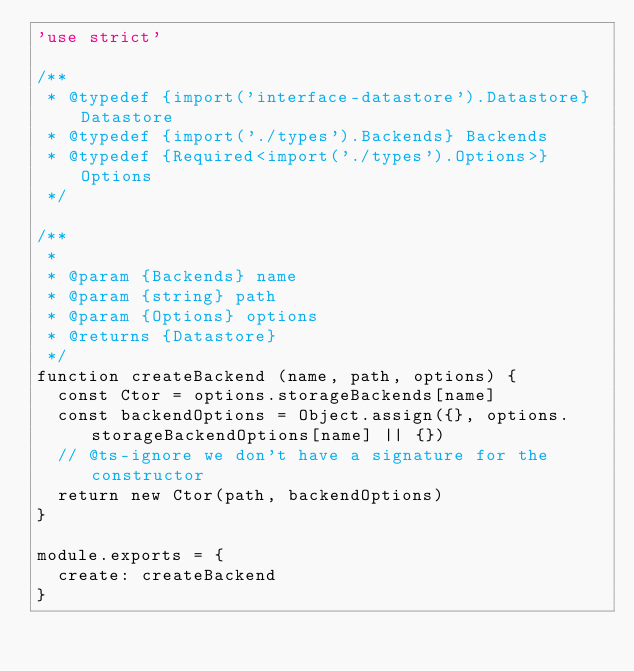<code> <loc_0><loc_0><loc_500><loc_500><_JavaScript_>'use strict'

/**
 * @typedef {import('interface-datastore').Datastore} Datastore
 * @typedef {import('./types').Backends} Backends
 * @typedef {Required<import('./types').Options>} Options
 */

/**
 *
 * @param {Backends} name
 * @param {string} path
 * @param {Options} options
 * @returns {Datastore}
 */
function createBackend (name, path, options) {
  const Ctor = options.storageBackends[name]
  const backendOptions = Object.assign({}, options.storageBackendOptions[name] || {})
  // @ts-ignore we don't have a signature for the constructor
  return new Ctor(path, backendOptions)
}

module.exports = {
  create: createBackend
}
</code> 